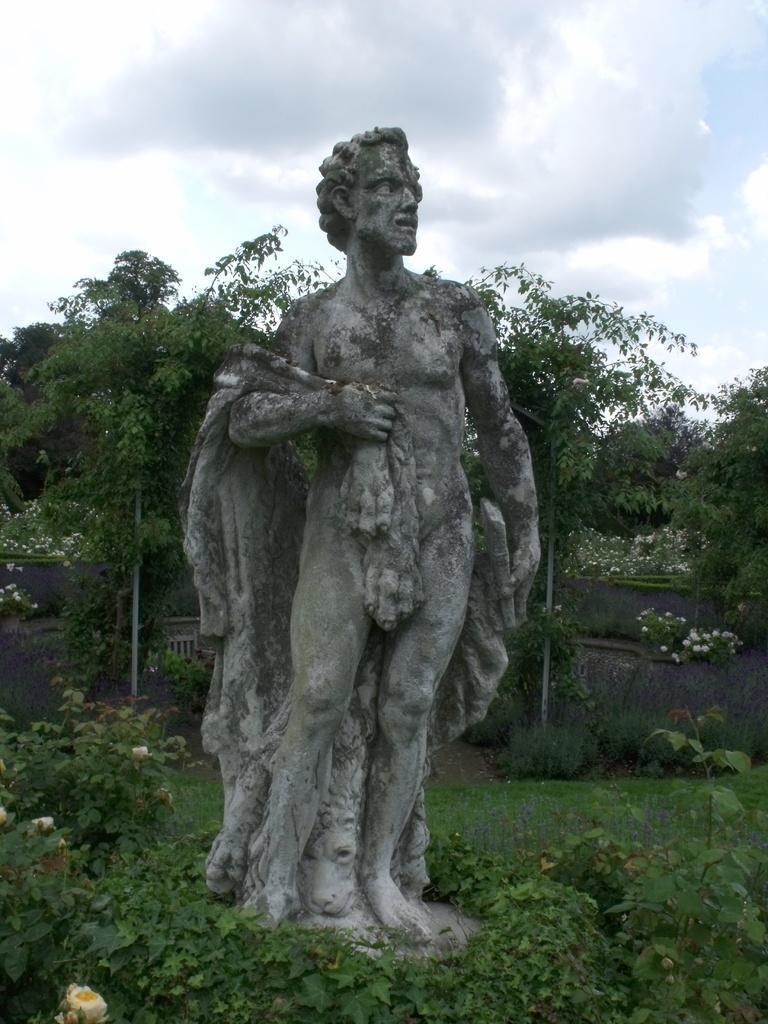In one or two sentences, can you explain what this image depicts? In this image there are plants, in the middle there is a sculpture, in the background there are trees and the sky. 